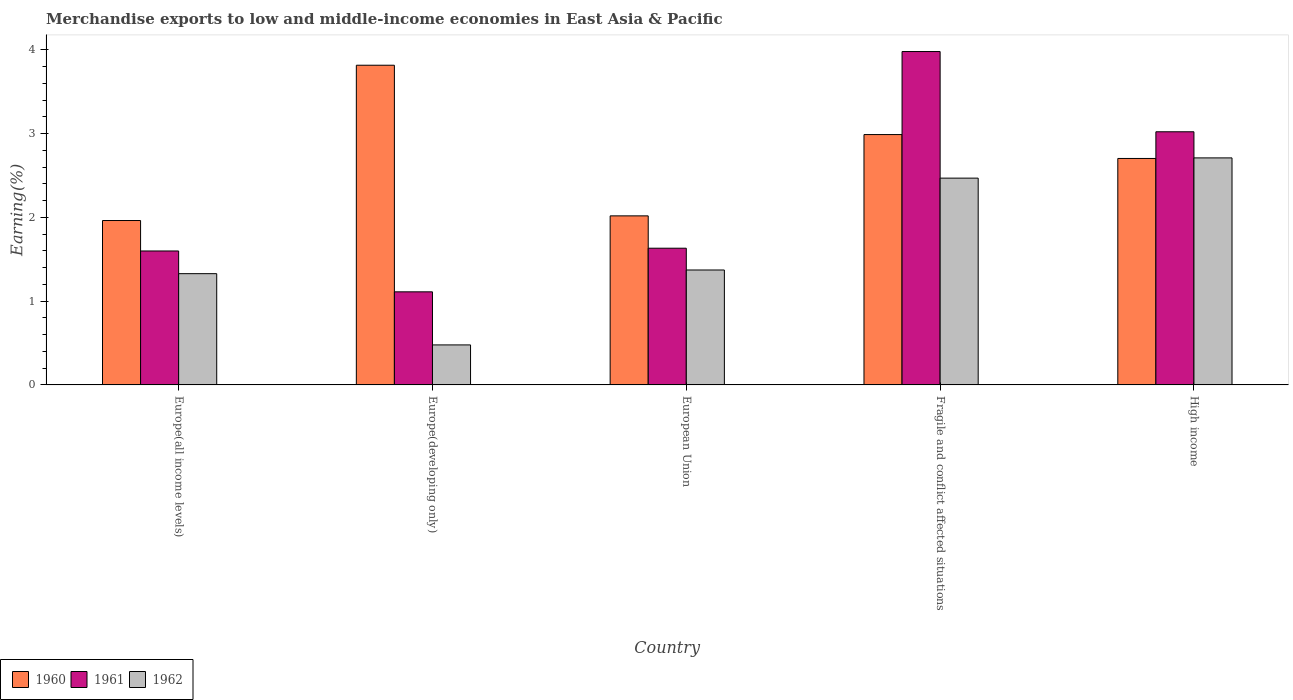How many groups of bars are there?
Offer a terse response. 5. Are the number of bars on each tick of the X-axis equal?
Make the answer very short. Yes. How many bars are there on the 3rd tick from the left?
Offer a very short reply. 3. How many bars are there on the 5th tick from the right?
Make the answer very short. 3. In how many cases, is the number of bars for a given country not equal to the number of legend labels?
Provide a short and direct response. 0. What is the percentage of amount earned from merchandise exports in 1961 in Europe(developing only)?
Offer a terse response. 1.11. Across all countries, what is the maximum percentage of amount earned from merchandise exports in 1961?
Your answer should be very brief. 3.98. Across all countries, what is the minimum percentage of amount earned from merchandise exports in 1961?
Your answer should be compact. 1.11. In which country was the percentage of amount earned from merchandise exports in 1961 maximum?
Give a very brief answer. Fragile and conflict affected situations. In which country was the percentage of amount earned from merchandise exports in 1961 minimum?
Offer a terse response. Europe(developing only). What is the total percentage of amount earned from merchandise exports in 1961 in the graph?
Give a very brief answer. 11.34. What is the difference between the percentage of amount earned from merchandise exports in 1962 in Europe(all income levels) and that in High income?
Your answer should be compact. -1.38. What is the difference between the percentage of amount earned from merchandise exports in 1961 in Europe(developing only) and the percentage of amount earned from merchandise exports in 1962 in Europe(all income levels)?
Keep it short and to the point. -0.22. What is the average percentage of amount earned from merchandise exports in 1962 per country?
Provide a succinct answer. 1.67. What is the difference between the percentage of amount earned from merchandise exports of/in 1960 and percentage of amount earned from merchandise exports of/in 1962 in Europe(developing only)?
Your answer should be very brief. 3.34. In how many countries, is the percentage of amount earned from merchandise exports in 1961 greater than 3.8 %?
Give a very brief answer. 1. What is the ratio of the percentage of amount earned from merchandise exports in 1962 in European Union to that in Fragile and conflict affected situations?
Offer a terse response. 0.56. Is the percentage of amount earned from merchandise exports in 1960 in Fragile and conflict affected situations less than that in High income?
Make the answer very short. No. What is the difference between the highest and the second highest percentage of amount earned from merchandise exports in 1960?
Your answer should be very brief. -0.83. What is the difference between the highest and the lowest percentage of amount earned from merchandise exports in 1961?
Your answer should be very brief. 2.87. In how many countries, is the percentage of amount earned from merchandise exports in 1962 greater than the average percentage of amount earned from merchandise exports in 1962 taken over all countries?
Your answer should be compact. 2. Is the sum of the percentage of amount earned from merchandise exports in 1960 in Europe(developing only) and Fragile and conflict affected situations greater than the maximum percentage of amount earned from merchandise exports in 1962 across all countries?
Provide a short and direct response. Yes. What does the 3rd bar from the right in Europe(all income levels) represents?
Your response must be concise. 1960. Is it the case that in every country, the sum of the percentage of amount earned from merchandise exports in 1960 and percentage of amount earned from merchandise exports in 1961 is greater than the percentage of amount earned from merchandise exports in 1962?
Give a very brief answer. Yes. Are all the bars in the graph horizontal?
Your response must be concise. No. What is the difference between two consecutive major ticks on the Y-axis?
Your answer should be very brief. 1. Does the graph contain any zero values?
Ensure brevity in your answer.  No. Does the graph contain grids?
Offer a very short reply. No. Where does the legend appear in the graph?
Offer a terse response. Bottom left. How many legend labels are there?
Give a very brief answer. 3. What is the title of the graph?
Your answer should be very brief. Merchandise exports to low and middle-income economies in East Asia & Pacific. Does "2006" appear as one of the legend labels in the graph?
Your answer should be compact. No. What is the label or title of the Y-axis?
Your answer should be compact. Earning(%). What is the Earning(%) of 1960 in Europe(all income levels)?
Provide a short and direct response. 1.96. What is the Earning(%) of 1961 in Europe(all income levels)?
Offer a very short reply. 1.6. What is the Earning(%) in 1962 in Europe(all income levels)?
Make the answer very short. 1.33. What is the Earning(%) of 1960 in Europe(developing only)?
Offer a very short reply. 3.82. What is the Earning(%) in 1961 in Europe(developing only)?
Your answer should be compact. 1.11. What is the Earning(%) in 1962 in Europe(developing only)?
Ensure brevity in your answer.  0.48. What is the Earning(%) in 1960 in European Union?
Offer a terse response. 2.02. What is the Earning(%) of 1961 in European Union?
Provide a succinct answer. 1.63. What is the Earning(%) in 1962 in European Union?
Make the answer very short. 1.37. What is the Earning(%) of 1960 in Fragile and conflict affected situations?
Ensure brevity in your answer.  2.99. What is the Earning(%) of 1961 in Fragile and conflict affected situations?
Ensure brevity in your answer.  3.98. What is the Earning(%) in 1962 in Fragile and conflict affected situations?
Provide a succinct answer. 2.47. What is the Earning(%) of 1960 in High income?
Make the answer very short. 2.7. What is the Earning(%) in 1961 in High income?
Provide a succinct answer. 3.02. What is the Earning(%) of 1962 in High income?
Keep it short and to the point. 2.71. Across all countries, what is the maximum Earning(%) in 1960?
Offer a terse response. 3.82. Across all countries, what is the maximum Earning(%) of 1961?
Offer a terse response. 3.98. Across all countries, what is the maximum Earning(%) of 1962?
Give a very brief answer. 2.71. Across all countries, what is the minimum Earning(%) of 1960?
Provide a short and direct response. 1.96. Across all countries, what is the minimum Earning(%) of 1961?
Your response must be concise. 1.11. Across all countries, what is the minimum Earning(%) in 1962?
Your answer should be compact. 0.48. What is the total Earning(%) of 1960 in the graph?
Give a very brief answer. 13.48. What is the total Earning(%) in 1961 in the graph?
Give a very brief answer. 11.34. What is the total Earning(%) in 1962 in the graph?
Make the answer very short. 8.35. What is the difference between the Earning(%) in 1960 in Europe(all income levels) and that in Europe(developing only)?
Ensure brevity in your answer.  -1.85. What is the difference between the Earning(%) of 1961 in Europe(all income levels) and that in Europe(developing only)?
Your response must be concise. 0.49. What is the difference between the Earning(%) in 1962 in Europe(all income levels) and that in Europe(developing only)?
Give a very brief answer. 0.85. What is the difference between the Earning(%) in 1960 in Europe(all income levels) and that in European Union?
Ensure brevity in your answer.  -0.06. What is the difference between the Earning(%) in 1961 in Europe(all income levels) and that in European Union?
Your answer should be compact. -0.03. What is the difference between the Earning(%) of 1962 in Europe(all income levels) and that in European Union?
Give a very brief answer. -0.04. What is the difference between the Earning(%) in 1960 in Europe(all income levels) and that in Fragile and conflict affected situations?
Give a very brief answer. -1.03. What is the difference between the Earning(%) in 1961 in Europe(all income levels) and that in Fragile and conflict affected situations?
Your response must be concise. -2.38. What is the difference between the Earning(%) in 1962 in Europe(all income levels) and that in Fragile and conflict affected situations?
Your answer should be very brief. -1.14. What is the difference between the Earning(%) of 1960 in Europe(all income levels) and that in High income?
Provide a succinct answer. -0.74. What is the difference between the Earning(%) of 1961 in Europe(all income levels) and that in High income?
Provide a short and direct response. -1.42. What is the difference between the Earning(%) of 1962 in Europe(all income levels) and that in High income?
Your response must be concise. -1.38. What is the difference between the Earning(%) in 1960 in Europe(developing only) and that in European Union?
Your answer should be very brief. 1.8. What is the difference between the Earning(%) of 1961 in Europe(developing only) and that in European Union?
Give a very brief answer. -0.52. What is the difference between the Earning(%) of 1962 in Europe(developing only) and that in European Union?
Provide a succinct answer. -0.89. What is the difference between the Earning(%) of 1960 in Europe(developing only) and that in Fragile and conflict affected situations?
Your response must be concise. 0.83. What is the difference between the Earning(%) of 1961 in Europe(developing only) and that in Fragile and conflict affected situations?
Your answer should be very brief. -2.87. What is the difference between the Earning(%) of 1962 in Europe(developing only) and that in Fragile and conflict affected situations?
Your answer should be very brief. -1.99. What is the difference between the Earning(%) in 1960 in Europe(developing only) and that in High income?
Your response must be concise. 1.11. What is the difference between the Earning(%) in 1961 in Europe(developing only) and that in High income?
Your answer should be very brief. -1.91. What is the difference between the Earning(%) in 1962 in Europe(developing only) and that in High income?
Make the answer very short. -2.23. What is the difference between the Earning(%) of 1960 in European Union and that in Fragile and conflict affected situations?
Offer a terse response. -0.97. What is the difference between the Earning(%) in 1961 in European Union and that in Fragile and conflict affected situations?
Offer a very short reply. -2.35. What is the difference between the Earning(%) of 1962 in European Union and that in Fragile and conflict affected situations?
Make the answer very short. -1.1. What is the difference between the Earning(%) in 1960 in European Union and that in High income?
Make the answer very short. -0.69. What is the difference between the Earning(%) in 1961 in European Union and that in High income?
Provide a succinct answer. -1.39. What is the difference between the Earning(%) in 1962 in European Union and that in High income?
Make the answer very short. -1.34. What is the difference between the Earning(%) in 1960 in Fragile and conflict affected situations and that in High income?
Your answer should be very brief. 0.29. What is the difference between the Earning(%) of 1961 in Fragile and conflict affected situations and that in High income?
Offer a terse response. 0.96. What is the difference between the Earning(%) of 1962 in Fragile and conflict affected situations and that in High income?
Make the answer very short. -0.24. What is the difference between the Earning(%) of 1960 in Europe(all income levels) and the Earning(%) of 1961 in Europe(developing only)?
Offer a very short reply. 0.85. What is the difference between the Earning(%) in 1960 in Europe(all income levels) and the Earning(%) in 1962 in Europe(developing only)?
Provide a succinct answer. 1.48. What is the difference between the Earning(%) in 1961 in Europe(all income levels) and the Earning(%) in 1962 in Europe(developing only)?
Make the answer very short. 1.12. What is the difference between the Earning(%) in 1960 in Europe(all income levels) and the Earning(%) in 1961 in European Union?
Make the answer very short. 0.33. What is the difference between the Earning(%) of 1960 in Europe(all income levels) and the Earning(%) of 1962 in European Union?
Make the answer very short. 0.59. What is the difference between the Earning(%) of 1961 in Europe(all income levels) and the Earning(%) of 1962 in European Union?
Your answer should be compact. 0.23. What is the difference between the Earning(%) of 1960 in Europe(all income levels) and the Earning(%) of 1961 in Fragile and conflict affected situations?
Ensure brevity in your answer.  -2.02. What is the difference between the Earning(%) of 1960 in Europe(all income levels) and the Earning(%) of 1962 in Fragile and conflict affected situations?
Offer a very short reply. -0.51. What is the difference between the Earning(%) in 1961 in Europe(all income levels) and the Earning(%) in 1962 in Fragile and conflict affected situations?
Make the answer very short. -0.87. What is the difference between the Earning(%) of 1960 in Europe(all income levels) and the Earning(%) of 1961 in High income?
Provide a short and direct response. -1.06. What is the difference between the Earning(%) in 1960 in Europe(all income levels) and the Earning(%) in 1962 in High income?
Offer a very short reply. -0.75. What is the difference between the Earning(%) of 1961 in Europe(all income levels) and the Earning(%) of 1962 in High income?
Your response must be concise. -1.11. What is the difference between the Earning(%) in 1960 in Europe(developing only) and the Earning(%) in 1961 in European Union?
Ensure brevity in your answer.  2.18. What is the difference between the Earning(%) of 1960 in Europe(developing only) and the Earning(%) of 1962 in European Union?
Ensure brevity in your answer.  2.44. What is the difference between the Earning(%) in 1961 in Europe(developing only) and the Earning(%) in 1962 in European Union?
Provide a succinct answer. -0.26. What is the difference between the Earning(%) in 1960 in Europe(developing only) and the Earning(%) in 1961 in Fragile and conflict affected situations?
Your answer should be very brief. -0.16. What is the difference between the Earning(%) in 1960 in Europe(developing only) and the Earning(%) in 1962 in Fragile and conflict affected situations?
Keep it short and to the point. 1.35. What is the difference between the Earning(%) in 1961 in Europe(developing only) and the Earning(%) in 1962 in Fragile and conflict affected situations?
Your answer should be compact. -1.36. What is the difference between the Earning(%) in 1960 in Europe(developing only) and the Earning(%) in 1961 in High income?
Give a very brief answer. 0.79. What is the difference between the Earning(%) of 1960 in Europe(developing only) and the Earning(%) of 1962 in High income?
Keep it short and to the point. 1.11. What is the difference between the Earning(%) in 1961 in Europe(developing only) and the Earning(%) in 1962 in High income?
Your answer should be very brief. -1.6. What is the difference between the Earning(%) of 1960 in European Union and the Earning(%) of 1961 in Fragile and conflict affected situations?
Your answer should be very brief. -1.96. What is the difference between the Earning(%) in 1960 in European Union and the Earning(%) in 1962 in Fragile and conflict affected situations?
Make the answer very short. -0.45. What is the difference between the Earning(%) in 1961 in European Union and the Earning(%) in 1962 in Fragile and conflict affected situations?
Your response must be concise. -0.84. What is the difference between the Earning(%) of 1960 in European Union and the Earning(%) of 1961 in High income?
Offer a terse response. -1. What is the difference between the Earning(%) of 1960 in European Union and the Earning(%) of 1962 in High income?
Ensure brevity in your answer.  -0.69. What is the difference between the Earning(%) of 1961 in European Union and the Earning(%) of 1962 in High income?
Offer a terse response. -1.08. What is the difference between the Earning(%) in 1960 in Fragile and conflict affected situations and the Earning(%) in 1961 in High income?
Your answer should be very brief. -0.03. What is the difference between the Earning(%) in 1960 in Fragile and conflict affected situations and the Earning(%) in 1962 in High income?
Your response must be concise. 0.28. What is the difference between the Earning(%) in 1961 in Fragile and conflict affected situations and the Earning(%) in 1962 in High income?
Your answer should be very brief. 1.27. What is the average Earning(%) in 1960 per country?
Your answer should be very brief. 2.7. What is the average Earning(%) of 1961 per country?
Your response must be concise. 2.27. What is the average Earning(%) in 1962 per country?
Your answer should be compact. 1.67. What is the difference between the Earning(%) in 1960 and Earning(%) in 1961 in Europe(all income levels)?
Provide a succinct answer. 0.36. What is the difference between the Earning(%) in 1960 and Earning(%) in 1962 in Europe(all income levels)?
Provide a succinct answer. 0.63. What is the difference between the Earning(%) in 1961 and Earning(%) in 1962 in Europe(all income levels)?
Make the answer very short. 0.27. What is the difference between the Earning(%) in 1960 and Earning(%) in 1961 in Europe(developing only)?
Provide a succinct answer. 2.7. What is the difference between the Earning(%) of 1960 and Earning(%) of 1962 in Europe(developing only)?
Your response must be concise. 3.34. What is the difference between the Earning(%) of 1961 and Earning(%) of 1962 in Europe(developing only)?
Offer a very short reply. 0.63. What is the difference between the Earning(%) in 1960 and Earning(%) in 1961 in European Union?
Make the answer very short. 0.39. What is the difference between the Earning(%) of 1960 and Earning(%) of 1962 in European Union?
Your response must be concise. 0.65. What is the difference between the Earning(%) in 1961 and Earning(%) in 1962 in European Union?
Your answer should be compact. 0.26. What is the difference between the Earning(%) of 1960 and Earning(%) of 1961 in Fragile and conflict affected situations?
Your answer should be compact. -0.99. What is the difference between the Earning(%) in 1960 and Earning(%) in 1962 in Fragile and conflict affected situations?
Provide a succinct answer. 0.52. What is the difference between the Earning(%) of 1961 and Earning(%) of 1962 in Fragile and conflict affected situations?
Give a very brief answer. 1.51. What is the difference between the Earning(%) in 1960 and Earning(%) in 1961 in High income?
Keep it short and to the point. -0.32. What is the difference between the Earning(%) in 1960 and Earning(%) in 1962 in High income?
Offer a very short reply. -0.01. What is the difference between the Earning(%) in 1961 and Earning(%) in 1962 in High income?
Ensure brevity in your answer.  0.31. What is the ratio of the Earning(%) of 1960 in Europe(all income levels) to that in Europe(developing only)?
Your answer should be compact. 0.51. What is the ratio of the Earning(%) of 1961 in Europe(all income levels) to that in Europe(developing only)?
Ensure brevity in your answer.  1.44. What is the ratio of the Earning(%) of 1962 in Europe(all income levels) to that in Europe(developing only)?
Provide a short and direct response. 2.78. What is the ratio of the Earning(%) of 1960 in Europe(all income levels) to that in European Union?
Offer a terse response. 0.97. What is the ratio of the Earning(%) of 1961 in Europe(all income levels) to that in European Union?
Provide a succinct answer. 0.98. What is the ratio of the Earning(%) of 1960 in Europe(all income levels) to that in Fragile and conflict affected situations?
Make the answer very short. 0.66. What is the ratio of the Earning(%) of 1961 in Europe(all income levels) to that in Fragile and conflict affected situations?
Your response must be concise. 0.4. What is the ratio of the Earning(%) of 1962 in Europe(all income levels) to that in Fragile and conflict affected situations?
Provide a short and direct response. 0.54. What is the ratio of the Earning(%) of 1960 in Europe(all income levels) to that in High income?
Your response must be concise. 0.73. What is the ratio of the Earning(%) in 1961 in Europe(all income levels) to that in High income?
Provide a short and direct response. 0.53. What is the ratio of the Earning(%) of 1962 in Europe(all income levels) to that in High income?
Offer a very short reply. 0.49. What is the ratio of the Earning(%) in 1960 in Europe(developing only) to that in European Union?
Make the answer very short. 1.89. What is the ratio of the Earning(%) of 1961 in Europe(developing only) to that in European Union?
Provide a short and direct response. 0.68. What is the ratio of the Earning(%) in 1962 in Europe(developing only) to that in European Union?
Offer a terse response. 0.35. What is the ratio of the Earning(%) in 1960 in Europe(developing only) to that in Fragile and conflict affected situations?
Your answer should be compact. 1.28. What is the ratio of the Earning(%) of 1961 in Europe(developing only) to that in Fragile and conflict affected situations?
Offer a very short reply. 0.28. What is the ratio of the Earning(%) in 1962 in Europe(developing only) to that in Fragile and conflict affected situations?
Your answer should be compact. 0.19. What is the ratio of the Earning(%) in 1960 in Europe(developing only) to that in High income?
Your answer should be very brief. 1.41. What is the ratio of the Earning(%) of 1961 in Europe(developing only) to that in High income?
Offer a very short reply. 0.37. What is the ratio of the Earning(%) in 1962 in Europe(developing only) to that in High income?
Offer a terse response. 0.18. What is the ratio of the Earning(%) of 1960 in European Union to that in Fragile and conflict affected situations?
Make the answer very short. 0.68. What is the ratio of the Earning(%) of 1961 in European Union to that in Fragile and conflict affected situations?
Keep it short and to the point. 0.41. What is the ratio of the Earning(%) in 1962 in European Union to that in Fragile and conflict affected situations?
Offer a very short reply. 0.56. What is the ratio of the Earning(%) of 1960 in European Union to that in High income?
Provide a succinct answer. 0.75. What is the ratio of the Earning(%) in 1961 in European Union to that in High income?
Give a very brief answer. 0.54. What is the ratio of the Earning(%) in 1962 in European Union to that in High income?
Provide a short and direct response. 0.51. What is the ratio of the Earning(%) in 1960 in Fragile and conflict affected situations to that in High income?
Ensure brevity in your answer.  1.11. What is the ratio of the Earning(%) of 1961 in Fragile and conflict affected situations to that in High income?
Your response must be concise. 1.32. What is the ratio of the Earning(%) of 1962 in Fragile and conflict affected situations to that in High income?
Ensure brevity in your answer.  0.91. What is the difference between the highest and the second highest Earning(%) of 1960?
Offer a very short reply. 0.83. What is the difference between the highest and the second highest Earning(%) of 1961?
Give a very brief answer. 0.96. What is the difference between the highest and the second highest Earning(%) in 1962?
Offer a terse response. 0.24. What is the difference between the highest and the lowest Earning(%) of 1960?
Give a very brief answer. 1.85. What is the difference between the highest and the lowest Earning(%) of 1961?
Keep it short and to the point. 2.87. What is the difference between the highest and the lowest Earning(%) in 1962?
Offer a terse response. 2.23. 